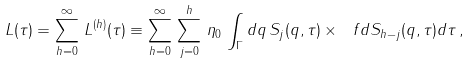<formula> <loc_0><loc_0><loc_500><loc_500>L ( \tau ) = \sum _ { h = 0 } ^ { \infty } \, L ^ { ( h ) } ( \tau ) \equiv \sum _ { h = 0 } ^ { \infty } \, \sum _ { j = 0 } ^ { h } \, \eta _ { 0 } \, \int _ { \Gamma } d q \, S _ { j } ( q , \tau ) \times \ f { d S _ { h - j } ( q , \tau ) } { d \tau } \, ,</formula> 